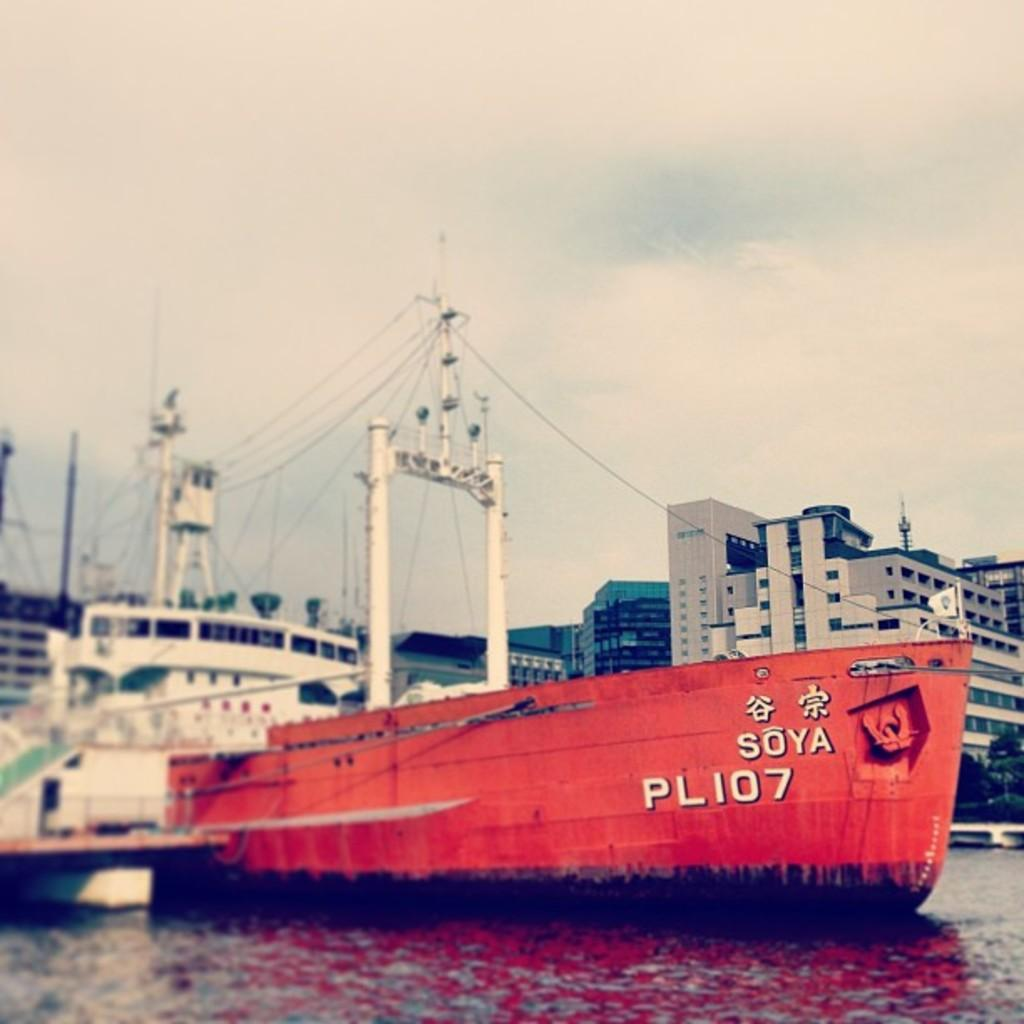What type of structures can be seen in the background of the image? There are buildings visible in the background of the image. What part of the natural environment is visible in the image? The sky is visible in the background of the image, and there are trees in the image. What type of vehicles can be seen in the image? There are ships in the image. What is the primary body of water in the image? There is water visible in the image. Can you describe any unspecified objects in the image? Unfortunately, the provided facts do not give any details about the unspecified objects in the image. How many cacti are present in the image? There is no mention of cacti in the provided facts, so it cannot be determined if any are present in the image. What type of light source is illuminating the scene in the image? The provided facts do not mention any light source, so it cannot be determined what is illuminating the scene in the image. 